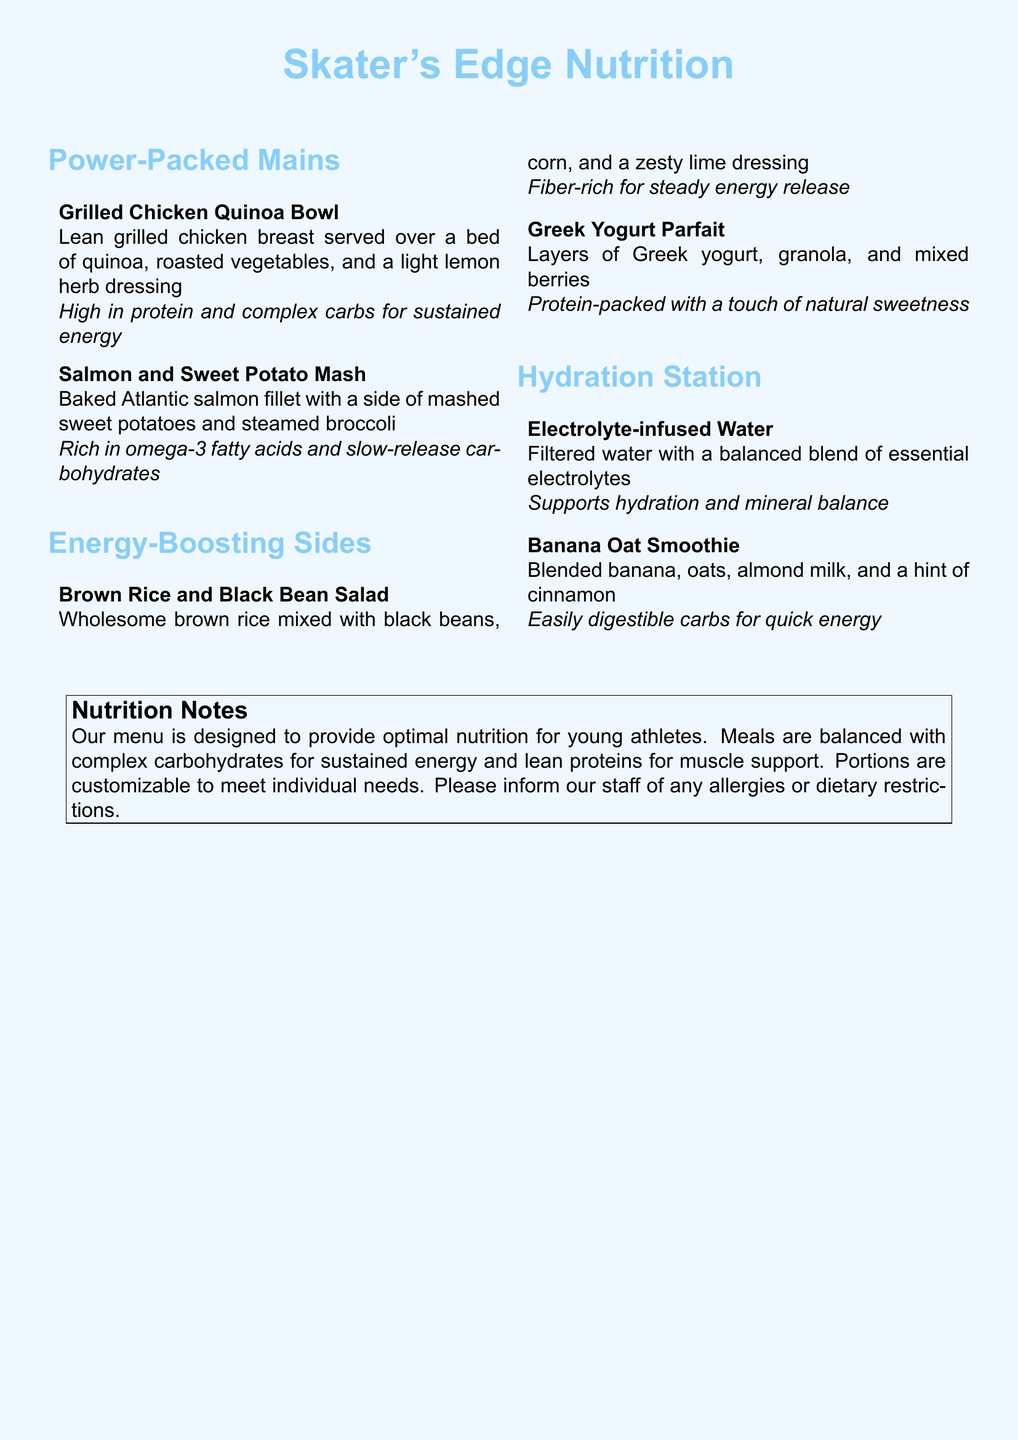What is the first main dish listed? The first main dish listed is the Grilled Chicken Quinoa Bowl.
Answer: Grilled Chicken Quinoa Bowl What is a key ingredient in the Salmon and Sweet Potato Mash? A key ingredient in the Salmon and Sweet Potato Mash is baked Atlantic salmon fillet.
Answer: Baked Atlantic salmon fillet What is the main protein source in the Greek Yogurt Parfait? The main protein source in the Greek Yogurt Parfait is Greek yogurt.
Answer: Greek yogurt Which side dish is rich in fiber? The Brown Rice and Black Bean Salad is rich in fiber.
Answer: Brown Rice and Black Bean Salad What type of water is offered at the Hydration Station? The type of water offered is Electrolyte-infused Water.
Answer: Electrolyte-infused Water What does the Nutrition Notes section indicate about the meal portions? The Nutrition Notes section indicates that portions are customizable to meet individual needs.
Answer: Customizable How many mains are listed in the menu? There are two mains listed in the menu.
Answer: Two What ingredient in the Banana Oat Smoothie provides quick energy? The ingredient providing quick energy is blended banana.
Answer: Blended banana What dietary focus does the menu emphasize? The menu emphasizes optimal nutrition for young athletes.
Answer: Optimal nutrition for young athletes 